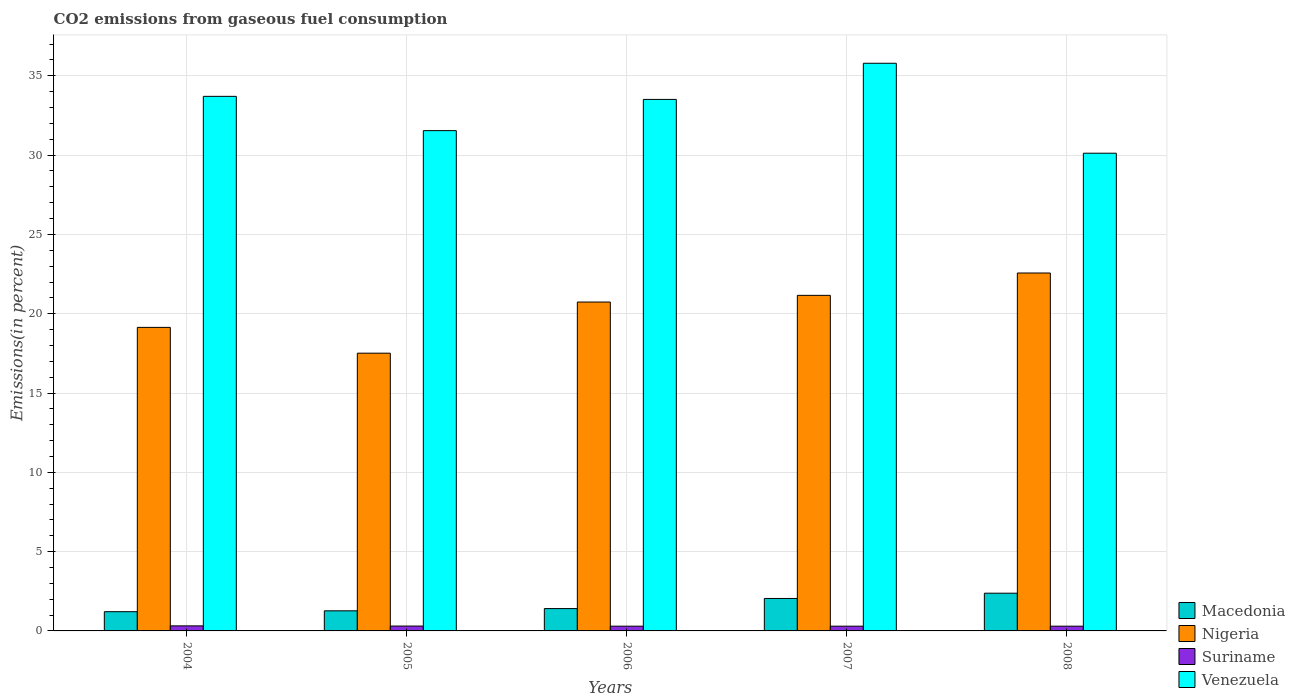How many groups of bars are there?
Provide a short and direct response. 5. Are the number of bars per tick equal to the number of legend labels?
Give a very brief answer. Yes. Are the number of bars on each tick of the X-axis equal?
Your response must be concise. Yes. How many bars are there on the 4th tick from the left?
Ensure brevity in your answer.  4. How many bars are there on the 3rd tick from the right?
Your response must be concise. 4. What is the label of the 2nd group of bars from the left?
Your response must be concise. 2005. In how many cases, is the number of bars for a given year not equal to the number of legend labels?
Give a very brief answer. 0. What is the total CO2 emitted in Macedonia in 2005?
Your answer should be very brief. 1.27. Across all years, what is the maximum total CO2 emitted in Suriname?
Provide a succinct answer. 0.32. Across all years, what is the minimum total CO2 emitted in Macedonia?
Your answer should be very brief. 1.21. In which year was the total CO2 emitted in Suriname maximum?
Provide a succinct answer. 2004. In which year was the total CO2 emitted in Venezuela minimum?
Offer a terse response. 2008. What is the total total CO2 emitted in Venezuela in the graph?
Make the answer very short. 164.68. What is the difference between the total CO2 emitted in Suriname in 2004 and that in 2008?
Give a very brief answer. 0.02. What is the difference between the total CO2 emitted in Venezuela in 2007 and the total CO2 emitted in Suriname in 2006?
Give a very brief answer. 35.49. What is the average total CO2 emitted in Suriname per year?
Offer a terse response. 0.3. In the year 2004, what is the difference between the total CO2 emitted in Macedonia and total CO2 emitted in Nigeria?
Your response must be concise. -17.93. What is the ratio of the total CO2 emitted in Venezuela in 2004 to that in 2008?
Your answer should be very brief. 1.12. Is the total CO2 emitted in Macedonia in 2005 less than that in 2006?
Keep it short and to the point. Yes. What is the difference between the highest and the second highest total CO2 emitted in Macedonia?
Offer a terse response. 0.33. What is the difference between the highest and the lowest total CO2 emitted in Macedonia?
Offer a terse response. 1.17. In how many years, is the total CO2 emitted in Suriname greater than the average total CO2 emitted in Suriname taken over all years?
Keep it short and to the point. 2. Is the sum of the total CO2 emitted in Venezuela in 2004 and 2008 greater than the maximum total CO2 emitted in Nigeria across all years?
Provide a succinct answer. Yes. What does the 3rd bar from the left in 2004 represents?
Provide a short and direct response. Suriname. What does the 3rd bar from the right in 2004 represents?
Give a very brief answer. Nigeria. Are all the bars in the graph horizontal?
Make the answer very short. No. What is the difference between two consecutive major ticks on the Y-axis?
Your answer should be very brief. 5. What is the title of the graph?
Keep it short and to the point. CO2 emissions from gaseous fuel consumption. What is the label or title of the Y-axis?
Your answer should be compact. Emissions(in percent). What is the Emissions(in percent) in Macedonia in 2004?
Offer a very short reply. 1.21. What is the Emissions(in percent) of Nigeria in 2004?
Your answer should be very brief. 19.14. What is the Emissions(in percent) in Suriname in 2004?
Offer a very short reply. 0.32. What is the Emissions(in percent) in Venezuela in 2004?
Make the answer very short. 33.71. What is the Emissions(in percent) in Macedonia in 2005?
Your answer should be very brief. 1.27. What is the Emissions(in percent) of Nigeria in 2005?
Make the answer very short. 17.51. What is the Emissions(in percent) of Suriname in 2005?
Give a very brief answer. 0.31. What is the Emissions(in percent) in Venezuela in 2005?
Make the answer very short. 31.54. What is the Emissions(in percent) in Macedonia in 2006?
Give a very brief answer. 1.41. What is the Emissions(in percent) in Nigeria in 2006?
Make the answer very short. 20.74. What is the Emissions(in percent) of Suriname in 2006?
Provide a succinct answer. 0.3. What is the Emissions(in percent) in Venezuela in 2006?
Your response must be concise. 33.51. What is the Emissions(in percent) of Macedonia in 2007?
Keep it short and to the point. 2.05. What is the Emissions(in percent) of Nigeria in 2007?
Make the answer very short. 21.16. What is the Emissions(in percent) in Suriname in 2007?
Your answer should be very brief. 0.3. What is the Emissions(in percent) in Venezuela in 2007?
Offer a very short reply. 35.79. What is the Emissions(in percent) in Macedonia in 2008?
Offer a terse response. 2.38. What is the Emissions(in percent) in Nigeria in 2008?
Keep it short and to the point. 22.57. What is the Emissions(in percent) in Suriname in 2008?
Give a very brief answer. 0.3. What is the Emissions(in percent) in Venezuela in 2008?
Ensure brevity in your answer.  30.12. Across all years, what is the maximum Emissions(in percent) of Macedonia?
Ensure brevity in your answer.  2.38. Across all years, what is the maximum Emissions(in percent) of Nigeria?
Provide a short and direct response. 22.57. Across all years, what is the maximum Emissions(in percent) of Suriname?
Offer a very short reply. 0.32. Across all years, what is the maximum Emissions(in percent) in Venezuela?
Offer a terse response. 35.79. Across all years, what is the minimum Emissions(in percent) in Macedonia?
Your answer should be very brief. 1.21. Across all years, what is the minimum Emissions(in percent) in Nigeria?
Your response must be concise. 17.51. Across all years, what is the minimum Emissions(in percent) in Suriname?
Provide a short and direct response. 0.3. Across all years, what is the minimum Emissions(in percent) of Venezuela?
Offer a very short reply. 30.12. What is the total Emissions(in percent) in Macedonia in the graph?
Offer a terse response. 8.31. What is the total Emissions(in percent) of Nigeria in the graph?
Make the answer very short. 101.11. What is the total Emissions(in percent) in Suriname in the graph?
Provide a short and direct response. 1.52. What is the total Emissions(in percent) of Venezuela in the graph?
Provide a succinct answer. 164.68. What is the difference between the Emissions(in percent) in Macedonia in 2004 and that in 2005?
Your answer should be very brief. -0.06. What is the difference between the Emissions(in percent) of Nigeria in 2004 and that in 2005?
Provide a short and direct response. 1.63. What is the difference between the Emissions(in percent) of Suriname in 2004 and that in 2005?
Provide a short and direct response. 0.01. What is the difference between the Emissions(in percent) in Venezuela in 2004 and that in 2005?
Offer a terse response. 2.16. What is the difference between the Emissions(in percent) in Macedonia in 2004 and that in 2006?
Your response must be concise. -0.2. What is the difference between the Emissions(in percent) in Nigeria in 2004 and that in 2006?
Your response must be concise. -1.6. What is the difference between the Emissions(in percent) in Suriname in 2004 and that in 2006?
Provide a succinct answer. 0.02. What is the difference between the Emissions(in percent) in Venezuela in 2004 and that in 2006?
Make the answer very short. 0.19. What is the difference between the Emissions(in percent) in Macedonia in 2004 and that in 2007?
Provide a short and direct response. -0.83. What is the difference between the Emissions(in percent) of Nigeria in 2004 and that in 2007?
Give a very brief answer. -2.02. What is the difference between the Emissions(in percent) of Suriname in 2004 and that in 2007?
Give a very brief answer. 0.02. What is the difference between the Emissions(in percent) in Venezuela in 2004 and that in 2007?
Offer a terse response. -2.09. What is the difference between the Emissions(in percent) of Macedonia in 2004 and that in 2008?
Give a very brief answer. -1.17. What is the difference between the Emissions(in percent) of Nigeria in 2004 and that in 2008?
Your answer should be compact. -3.43. What is the difference between the Emissions(in percent) in Venezuela in 2004 and that in 2008?
Ensure brevity in your answer.  3.59. What is the difference between the Emissions(in percent) in Macedonia in 2005 and that in 2006?
Ensure brevity in your answer.  -0.14. What is the difference between the Emissions(in percent) in Nigeria in 2005 and that in 2006?
Give a very brief answer. -3.22. What is the difference between the Emissions(in percent) in Suriname in 2005 and that in 2006?
Your answer should be very brief. 0.01. What is the difference between the Emissions(in percent) in Venezuela in 2005 and that in 2006?
Offer a terse response. -1.97. What is the difference between the Emissions(in percent) in Macedonia in 2005 and that in 2007?
Provide a short and direct response. -0.78. What is the difference between the Emissions(in percent) in Nigeria in 2005 and that in 2007?
Give a very brief answer. -3.65. What is the difference between the Emissions(in percent) of Suriname in 2005 and that in 2007?
Provide a succinct answer. 0.01. What is the difference between the Emissions(in percent) in Venezuela in 2005 and that in 2007?
Provide a succinct answer. -4.25. What is the difference between the Emissions(in percent) in Macedonia in 2005 and that in 2008?
Offer a terse response. -1.11. What is the difference between the Emissions(in percent) of Nigeria in 2005 and that in 2008?
Make the answer very short. -5.06. What is the difference between the Emissions(in percent) of Suriname in 2005 and that in 2008?
Ensure brevity in your answer.  0.01. What is the difference between the Emissions(in percent) in Venezuela in 2005 and that in 2008?
Ensure brevity in your answer.  1.42. What is the difference between the Emissions(in percent) in Macedonia in 2006 and that in 2007?
Give a very brief answer. -0.64. What is the difference between the Emissions(in percent) of Nigeria in 2006 and that in 2007?
Your answer should be very brief. -0.42. What is the difference between the Emissions(in percent) in Suriname in 2006 and that in 2007?
Make the answer very short. 0. What is the difference between the Emissions(in percent) in Venezuela in 2006 and that in 2007?
Keep it short and to the point. -2.28. What is the difference between the Emissions(in percent) of Macedonia in 2006 and that in 2008?
Provide a short and direct response. -0.97. What is the difference between the Emissions(in percent) in Nigeria in 2006 and that in 2008?
Make the answer very short. -1.83. What is the difference between the Emissions(in percent) of Suriname in 2006 and that in 2008?
Make the answer very short. 0. What is the difference between the Emissions(in percent) of Venezuela in 2006 and that in 2008?
Ensure brevity in your answer.  3.39. What is the difference between the Emissions(in percent) of Macedonia in 2007 and that in 2008?
Offer a terse response. -0.33. What is the difference between the Emissions(in percent) of Nigeria in 2007 and that in 2008?
Your answer should be very brief. -1.41. What is the difference between the Emissions(in percent) in Venezuela in 2007 and that in 2008?
Offer a very short reply. 5.67. What is the difference between the Emissions(in percent) in Macedonia in 2004 and the Emissions(in percent) in Nigeria in 2005?
Your response must be concise. -16.3. What is the difference between the Emissions(in percent) of Macedonia in 2004 and the Emissions(in percent) of Suriname in 2005?
Provide a short and direct response. 0.91. What is the difference between the Emissions(in percent) in Macedonia in 2004 and the Emissions(in percent) in Venezuela in 2005?
Provide a short and direct response. -30.33. What is the difference between the Emissions(in percent) in Nigeria in 2004 and the Emissions(in percent) in Suriname in 2005?
Provide a short and direct response. 18.83. What is the difference between the Emissions(in percent) in Nigeria in 2004 and the Emissions(in percent) in Venezuela in 2005?
Offer a terse response. -12.41. What is the difference between the Emissions(in percent) of Suriname in 2004 and the Emissions(in percent) of Venezuela in 2005?
Ensure brevity in your answer.  -31.23. What is the difference between the Emissions(in percent) of Macedonia in 2004 and the Emissions(in percent) of Nigeria in 2006?
Your response must be concise. -19.52. What is the difference between the Emissions(in percent) in Macedonia in 2004 and the Emissions(in percent) in Suriname in 2006?
Provide a succinct answer. 0.91. What is the difference between the Emissions(in percent) in Macedonia in 2004 and the Emissions(in percent) in Venezuela in 2006?
Keep it short and to the point. -32.3. What is the difference between the Emissions(in percent) of Nigeria in 2004 and the Emissions(in percent) of Suriname in 2006?
Keep it short and to the point. 18.84. What is the difference between the Emissions(in percent) of Nigeria in 2004 and the Emissions(in percent) of Venezuela in 2006?
Make the answer very short. -14.37. What is the difference between the Emissions(in percent) in Suriname in 2004 and the Emissions(in percent) in Venezuela in 2006?
Provide a short and direct response. -33.19. What is the difference between the Emissions(in percent) in Macedonia in 2004 and the Emissions(in percent) in Nigeria in 2007?
Provide a short and direct response. -19.95. What is the difference between the Emissions(in percent) in Macedonia in 2004 and the Emissions(in percent) in Suriname in 2007?
Keep it short and to the point. 0.91. What is the difference between the Emissions(in percent) of Macedonia in 2004 and the Emissions(in percent) of Venezuela in 2007?
Make the answer very short. -34.58. What is the difference between the Emissions(in percent) in Nigeria in 2004 and the Emissions(in percent) in Suriname in 2007?
Keep it short and to the point. 18.84. What is the difference between the Emissions(in percent) of Nigeria in 2004 and the Emissions(in percent) of Venezuela in 2007?
Keep it short and to the point. -16.65. What is the difference between the Emissions(in percent) of Suriname in 2004 and the Emissions(in percent) of Venezuela in 2007?
Your response must be concise. -35.47. What is the difference between the Emissions(in percent) of Macedonia in 2004 and the Emissions(in percent) of Nigeria in 2008?
Offer a terse response. -21.36. What is the difference between the Emissions(in percent) in Macedonia in 2004 and the Emissions(in percent) in Suriname in 2008?
Offer a very short reply. 0.91. What is the difference between the Emissions(in percent) of Macedonia in 2004 and the Emissions(in percent) of Venezuela in 2008?
Provide a short and direct response. -28.91. What is the difference between the Emissions(in percent) in Nigeria in 2004 and the Emissions(in percent) in Suriname in 2008?
Offer a terse response. 18.84. What is the difference between the Emissions(in percent) in Nigeria in 2004 and the Emissions(in percent) in Venezuela in 2008?
Offer a very short reply. -10.98. What is the difference between the Emissions(in percent) of Suriname in 2004 and the Emissions(in percent) of Venezuela in 2008?
Provide a short and direct response. -29.8. What is the difference between the Emissions(in percent) of Macedonia in 2005 and the Emissions(in percent) of Nigeria in 2006?
Provide a succinct answer. -19.47. What is the difference between the Emissions(in percent) in Macedonia in 2005 and the Emissions(in percent) in Suriname in 2006?
Ensure brevity in your answer.  0.97. What is the difference between the Emissions(in percent) in Macedonia in 2005 and the Emissions(in percent) in Venezuela in 2006?
Provide a short and direct response. -32.24. What is the difference between the Emissions(in percent) in Nigeria in 2005 and the Emissions(in percent) in Suriname in 2006?
Provide a short and direct response. 17.21. What is the difference between the Emissions(in percent) of Nigeria in 2005 and the Emissions(in percent) of Venezuela in 2006?
Keep it short and to the point. -16. What is the difference between the Emissions(in percent) of Suriname in 2005 and the Emissions(in percent) of Venezuela in 2006?
Your response must be concise. -33.21. What is the difference between the Emissions(in percent) in Macedonia in 2005 and the Emissions(in percent) in Nigeria in 2007?
Give a very brief answer. -19.89. What is the difference between the Emissions(in percent) of Macedonia in 2005 and the Emissions(in percent) of Suriname in 2007?
Keep it short and to the point. 0.97. What is the difference between the Emissions(in percent) of Macedonia in 2005 and the Emissions(in percent) of Venezuela in 2007?
Your answer should be very brief. -34.52. What is the difference between the Emissions(in percent) in Nigeria in 2005 and the Emissions(in percent) in Suriname in 2007?
Provide a short and direct response. 17.21. What is the difference between the Emissions(in percent) of Nigeria in 2005 and the Emissions(in percent) of Venezuela in 2007?
Offer a terse response. -18.28. What is the difference between the Emissions(in percent) of Suriname in 2005 and the Emissions(in percent) of Venezuela in 2007?
Ensure brevity in your answer.  -35.49. What is the difference between the Emissions(in percent) of Macedonia in 2005 and the Emissions(in percent) of Nigeria in 2008?
Your answer should be compact. -21.3. What is the difference between the Emissions(in percent) of Macedonia in 2005 and the Emissions(in percent) of Suriname in 2008?
Offer a terse response. 0.97. What is the difference between the Emissions(in percent) in Macedonia in 2005 and the Emissions(in percent) in Venezuela in 2008?
Provide a succinct answer. -28.85. What is the difference between the Emissions(in percent) in Nigeria in 2005 and the Emissions(in percent) in Suriname in 2008?
Ensure brevity in your answer.  17.21. What is the difference between the Emissions(in percent) in Nigeria in 2005 and the Emissions(in percent) in Venezuela in 2008?
Your answer should be compact. -12.61. What is the difference between the Emissions(in percent) of Suriname in 2005 and the Emissions(in percent) of Venezuela in 2008?
Your answer should be compact. -29.81. What is the difference between the Emissions(in percent) in Macedonia in 2006 and the Emissions(in percent) in Nigeria in 2007?
Keep it short and to the point. -19.75. What is the difference between the Emissions(in percent) of Macedonia in 2006 and the Emissions(in percent) of Suriname in 2007?
Offer a very short reply. 1.11. What is the difference between the Emissions(in percent) of Macedonia in 2006 and the Emissions(in percent) of Venezuela in 2007?
Your answer should be very brief. -34.38. What is the difference between the Emissions(in percent) of Nigeria in 2006 and the Emissions(in percent) of Suriname in 2007?
Your response must be concise. 20.44. What is the difference between the Emissions(in percent) in Nigeria in 2006 and the Emissions(in percent) in Venezuela in 2007?
Offer a terse response. -15.06. What is the difference between the Emissions(in percent) in Suriname in 2006 and the Emissions(in percent) in Venezuela in 2007?
Ensure brevity in your answer.  -35.49. What is the difference between the Emissions(in percent) of Macedonia in 2006 and the Emissions(in percent) of Nigeria in 2008?
Make the answer very short. -21.16. What is the difference between the Emissions(in percent) of Macedonia in 2006 and the Emissions(in percent) of Suriname in 2008?
Keep it short and to the point. 1.11. What is the difference between the Emissions(in percent) in Macedonia in 2006 and the Emissions(in percent) in Venezuela in 2008?
Provide a succinct answer. -28.71. What is the difference between the Emissions(in percent) of Nigeria in 2006 and the Emissions(in percent) of Suriname in 2008?
Ensure brevity in your answer.  20.44. What is the difference between the Emissions(in percent) in Nigeria in 2006 and the Emissions(in percent) in Venezuela in 2008?
Keep it short and to the point. -9.38. What is the difference between the Emissions(in percent) of Suriname in 2006 and the Emissions(in percent) of Venezuela in 2008?
Ensure brevity in your answer.  -29.82. What is the difference between the Emissions(in percent) in Macedonia in 2007 and the Emissions(in percent) in Nigeria in 2008?
Keep it short and to the point. -20.52. What is the difference between the Emissions(in percent) of Macedonia in 2007 and the Emissions(in percent) of Suriname in 2008?
Your response must be concise. 1.75. What is the difference between the Emissions(in percent) of Macedonia in 2007 and the Emissions(in percent) of Venezuela in 2008?
Provide a succinct answer. -28.07. What is the difference between the Emissions(in percent) in Nigeria in 2007 and the Emissions(in percent) in Suriname in 2008?
Provide a succinct answer. 20.86. What is the difference between the Emissions(in percent) of Nigeria in 2007 and the Emissions(in percent) of Venezuela in 2008?
Give a very brief answer. -8.96. What is the difference between the Emissions(in percent) of Suriname in 2007 and the Emissions(in percent) of Venezuela in 2008?
Provide a succinct answer. -29.82. What is the average Emissions(in percent) in Macedonia per year?
Offer a terse response. 1.66. What is the average Emissions(in percent) of Nigeria per year?
Make the answer very short. 20.22. What is the average Emissions(in percent) of Suriname per year?
Your answer should be compact. 0.3. What is the average Emissions(in percent) in Venezuela per year?
Your answer should be very brief. 32.94. In the year 2004, what is the difference between the Emissions(in percent) in Macedonia and Emissions(in percent) in Nigeria?
Offer a very short reply. -17.93. In the year 2004, what is the difference between the Emissions(in percent) in Macedonia and Emissions(in percent) in Suriname?
Give a very brief answer. 0.89. In the year 2004, what is the difference between the Emissions(in percent) of Macedonia and Emissions(in percent) of Venezuela?
Provide a succinct answer. -32.49. In the year 2004, what is the difference between the Emissions(in percent) of Nigeria and Emissions(in percent) of Suriname?
Provide a succinct answer. 18.82. In the year 2004, what is the difference between the Emissions(in percent) of Nigeria and Emissions(in percent) of Venezuela?
Your answer should be compact. -14.57. In the year 2004, what is the difference between the Emissions(in percent) of Suriname and Emissions(in percent) of Venezuela?
Your answer should be very brief. -33.39. In the year 2005, what is the difference between the Emissions(in percent) of Macedonia and Emissions(in percent) of Nigeria?
Your answer should be very brief. -16.24. In the year 2005, what is the difference between the Emissions(in percent) of Macedonia and Emissions(in percent) of Suriname?
Provide a succinct answer. 0.96. In the year 2005, what is the difference between the Emissions(in percent) in Macedonia and Emissions(in percent) in Venezuela?
Give a very brief answer. -30.28. In the year 2005, what is the difference between the Emissions(in percent) of Nigeria and Emissions(in percent) of Suriname?
Offer a very short reply. 17.21. In the year 2005, what is the difference between the Emissions(in percent) in Nigeria and Emissions(in percent) in Venezuela?
Offer a very short reply. -14.03. In the year 2005, what is the difference between the Emissions(in percent) of Suriname and Emissions(in percent) of Venezuela?
Provide a succinct answer. -31.24. In the year 2006, what is the difference between the Emissions(in percent) in Macedonia and Emissions(in percent) in Nigeria?
Offer a very short reply. -19.33. In the year 2006, what is the difference between the Emissions(in percent) of Macedonia and Emissions(in percent) of Suriname?
Your answer should be compact. 1.11. In the year 2006, what is the difference between the Emissions(in percent) in Macedonia and Emissions(in percent) in Venezuela?
Offer a terse response. -32.1. In the year 2006, what is the difference between the Emissions(in percent) in Nigeria and Emissions(in percent) in Suriname?
Give a very brief answer. 20.44. In the year 2006, what is the difference between the Emissions(in percent) of Nigeria and Emissions(in percent) of Venezuela?
Ensure brevity in your answer.  -12.78. In the year 2006, what is the difference between the Emissions(in percent) in Suriname and Emissions(in percent) in Venezuela?
Your response must be concise. -33.21. In the year 2007, what is the difference between the Emissions(in percent) in Macedonia and Emissions(in percent) in Nigeria?
Your answer should be compact. -19.11. In the year 2007, what is the difference between the Emissions(in percent) of Macedonia and Emissions(in percent) of Suriname?
Offer a very short reply. 1.75. In the year 2007, what is the difference between the Emissions(in percent) in Macedonia and Emissions(in percent) in Venezuela?
Your answer should be very brief. -33.75. In the year 2007, what is the difference between the Emissions(in percent) in Nigeria and Emissions(in percent) in Suriname?
Offer a very short reply. 20.86. In the year 2007, what is the difference between the Emissions(in percent) of Nigeria and Emissions(in percent) of Venezuela?
Give a very brief answer. -14.63. In the year 2007, what is the difference between the Emissions(in percent) of Suriname and Emissions(in percent) of Venezuela?
Give a very brief answer. -35.49. In the year 2008, what is the difference between the Emissions(in percent) in Macedonia and Emissions(in percent) in Nigeria?
Offer a terse response. -20.19. In the year 2008, what is the difference between the Emissions(in percent) in Macedonia and Emissions(in percent) in Suriname?
Offer a terse response. 2.08. In the year 2008, what is the difference between the Emissions(in percent) in Macedonia and Emissions(in percent) in Venezuela?
Keep it short and to the point. -27.74. In the year 2008, what is the difference between the Emissions(in percent) of Nigeria and Emissions(in percent) of Suriname?
Offer a terse response. 22.27. In the year 2008, what is the difference between the Emissions(in percent) of Nigeria and Emissions(in percent) of Venezuela?
Your answer should be very brief. -7.55. In the year 2008, what is the difference between the Emissions(in percent) of Suriname and Emissions(in percent) of Venezuela?
Offer a terse response. -29.82. What is the ratio of the Emissions(in percent) of Macedonia in 2004 to that in 2005?
Your answer should be very brief. 0.96. What is the ratio of the Emissions(in percent) of Nigeria in 2004 to that in 2005?
Your answer should be very brief. 1.09. What is the ratio of the Emissions(in percent) of Suriname in 2004 to that in 2005?
Your answer should be very brief. 1.04. What is the ratio of the Emissions(in percent) of Venezuela in 2004 to that in 2005?
Make the answer very short. 1.07. What is the ratio of the Emissions(in percent) in Macedonia in 2004 to that in 2006?
Give a very brief answer. 0.86. What is the ratio of the Emissions(in percent) in Nigeria in 2004 to that in 2006?
Give a very brief answer. 0.92. What is the ratio of the Emissions(in percent) in Suriname in 2004 to that in 2006?
Your response must be concise. 1.07. What is the ratio of the Emissions(in percent) in Macedonia in 2004 to that in 2007?
Provide a short and direct response. 0.59. What is the ratio of the Emissions(in percent) of Nigeria in 2004 to that in 2007?
Make the answer very short. 0.9. What is the ratio of the Emissions(in percent) of Suriname in 2004 to that in 2007?
Your answer should be compact. 1.07. What is the ratio of the Emissions(in percent) in Venezuela in 2004 to that in 2007?
Keep it short and to the point. 0.94. What is the ratio of the Emissions(in percent) in Macedonia in 2004 to that in 2008?
Offer a very short reply. 0.51. What is the ratio of the Emissions(in percent) in Nigeria in 2004 to that in 2008?
Your answer should be compact. 0.85. What is the ratio of the Emissions(in percent) of Suriname in 2004 to that in 2008?
Provide a succinct answer. 1.07. What is the ratio of the Emissions(in percent) in Venezuela in 2004 to that in 2008?
Make the answer very short. 1.12. What is the ratio of the Emissions(in percent) in Macedonia in 2005 to that in 2006?
Ensure brevity in your answer.  0.9. What is the ratio of the Emissions(in percent) of Nigeria in 2005 to that in 2006?
Provide a short and direct response. 0.84. What is the ratio of the Emissions(in percent) in Suriname in 2005 to that in 2006?
Provide a short and direct response. 1.03. What is the ratio of the Emissions(in percent) of Venezuela in 2005 to that in 2006?
Offer a very short reply. 0.94. What is the ratio of the Emissions(in percent) of Macedonia in 2005 to that in 2007?
Provide a short and direct response. 0.62. What is the ratio of the Emissions(in percent) of Nigeria in 2005 to that in 2007?
Provide a short and direct response. 0.83. What is the ratio of the Emissions(in percent) in Suriname in 2005 to that in 2007?
Keep it short and to the point. 1.03. What is the ratio of the Emissions(in percent) in Venezuela in 2005 to that in 2007?
Your response must be concise. 0.88. What is the ratio of the Emissions(in percent) of Macedonia in 2005 to that in 2008?
Your answer should be compact. 0.53. What is the ratio of the Emissions(in percent) in Nigeria in 2005 to that in 2008?
Make the answer very short. 0.78. What is the ratio of the Emissions(in percent) in Suriname in 2005 to that in 2008?
Give a very brief answer. 1.03. What is the ratio of the Emissions(in percent) in Venezuela in 2005 to that in 2008?
Provide a short and direct response. 1.05. What is the ratio of the Emissions(in percent) of Macedonia in 2006 to that in 2007?
Offer a very short reply. 0.69. What is the ratio of the Emissions(in percent) of Nigeria in 2006 to that in 2007?
Ensure brevity in your answer.  0.98. What is the ratio of the Emissions(in percent) in Venezuela in 2006 to that in 2007?
Offer a very short reply. 0.94. What is the ratio of the Emissions(in percent) in Macedonia in 2006 to that in 2008?
Provide a succinct answer. 0.59. What is the ratio of the Emissions(in percent) of Nigeria in 2006 to that in 2008?
Give a very brief answer. 0.92. What is the ratio of the Emissions(in percent) in Suriname in 2006 to that in 2008?
Offer a terse response. 1. What is the ratio of the Emissions(in percent) in Venezuela in 2006 to that in 2008?
Offer a very short reply. 1.11. What is the ratio of the Emissions(in percent) in Macedonia in 2007 to that in 2008?
Give a very brief answer. 0.86. What is the ratio of the Emissions(in percent) in Nigeria in 2007 to that in 2008?
Offer a terse response. 0.94. What is the ratio of the Emissions(in percent) in Venezuela in 2007 to that in 2008?
Your answer should be compact. 1.19. What is the difference between the highest and the second highest Emissions(in percent) of Macedonia?
Ensure brevity in your answer.  0.33. What is the difference between the highest and the second highest Emissions(in percent) of Nigeria?
Your answer should be compact. 1.41. What is the difference between the highest and the second highest Emissions(in percent) of Suriname?
Provide a short and direct response. 0.01. What is the difference between the highest and the second highest Emissions(in percent) in Venezuela?
Your response must be concise. 2.09. What is the difference between the highest and the lowest Emissions(in percent) of Macedonia?
Provide a succinct answer. 1.17. What is the difference between the highest and the lowest Emissions(in percent) of Nigeria?
Offer a very short reply. 5.06. What is the difference between the highest and the lowest Emissions(in percent) of Venezuela?
Keep it short and to the point. 5.67. 